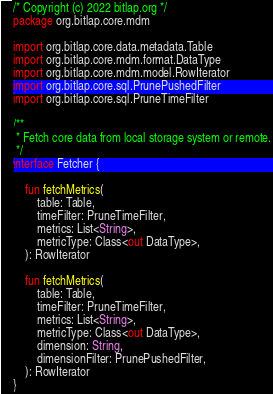Convert code to text. <code><loc_0><loc_0><loc_500><loc_500><_Kotlin_>/* Copyright (c) 2022 bitlap.org */
package org.bitlap.core.mdm

import org.bitlap.core.data.metadata.Table
import org.bitlap.core.mdm.format.DataType
import org.bitlap.core.mdm.model.RowIterator
import org.bitlap.core.sql.PrunePushedFilter
import org.bitlap.core.sql.PruneTimeFilter

/**
 * Fetch core data from local storage system or remote.
 */
interface Fetcher {

    fun fetchMetrics(
        table: Table,
        timeFilter: PruneTimeFilter,
        metrics: List<String>,
        metricType: Class<out DataType>,
    ): RowIterator

    fun fetchMetrics(
        table: Table,
        timeFilter: PruneTimeFilter,
        metrics: List<String>,
        metricType: Class<out DataType>,
        dimension: String,
        dimensionFilter: PrunePushedFilter,
    ): RowIterator
}
</code> 